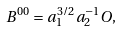Convert formula to latex. <formula><loc_0><loc_0><loc_500><loc_500>B ^ { 0 0 } = a _ { 1 } ^ { 3 / 2 } a _ { 2 } ^ { - 1 } O ,</formula> 